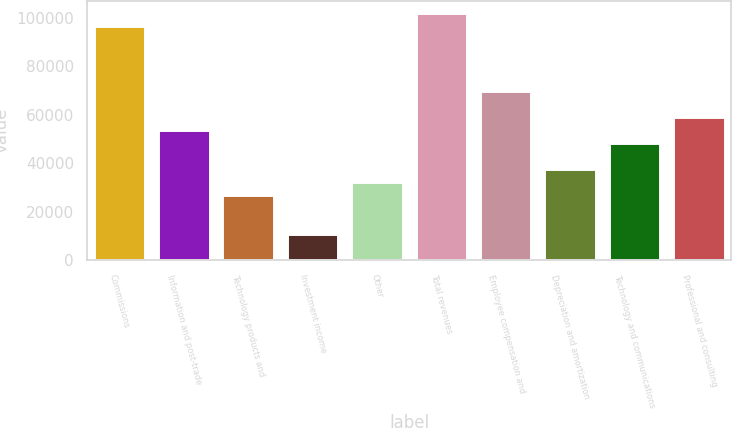<chart> <loc_0><loc_0><loc_500><loc_500><bar_chart><fcel>Commissions<fcel>Information and post-trade<fcel>Technology products and<fcel>Investment income<fcel>Other<fcel>Total revenues<fcel>Employee compensation and<fcel>Depreciation and amortization<fcel>Technology and communications<fcel>Professional and consulting<nl><fcel>96571.5<fcel>53651<fcel>26825.7<fcel>10730.5<fcel>32190.8<fcel>101937<fcel>69746.2<fcel>37555.8<fcel>48285.9<fcel>59016.1<nl></chart> 